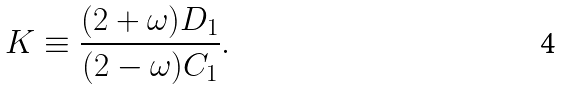<formula> <loc_0><loc_0><loc_500><loc_500>K \equiv \frac { ( 2 + \omega ) D _ { 1 } } { ( 2 - \omega ) C _ { 1 } } .</formula> 